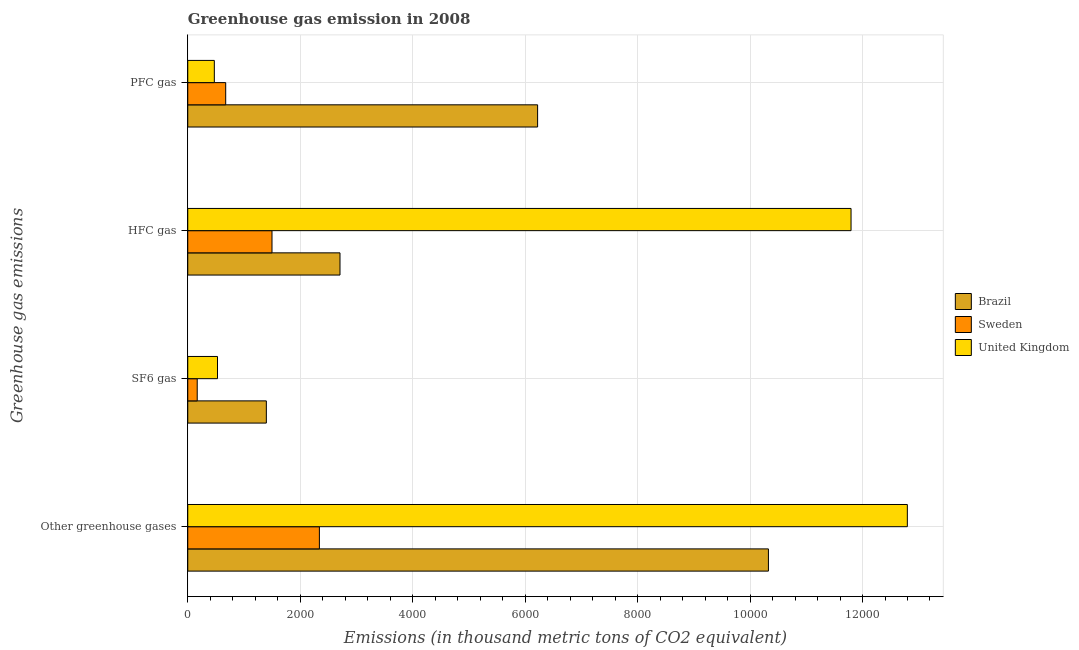How many groups of bars are there?
Make the answer very short. 4. Are the number of bars per tick equal to the number of legend labels?
Ensure brevity in your answer.  Yes. Are the number of bars on each tick of the Y-axis equal?
Keep it short and to the point. Yes. How many bars are there on the 1st tick from the top?
Offer a terse response. 3. How many bars are there on the 1st tick from the bottom?
Provide a short and direct response. 3. What is the label of the 3rd group of bars from the top?
Provide a succinct answer. SF6 gas. What is the emission of sf6 gas in United Kingdom?
Ensure brevity in your answer.  528.9. Across all countries, what is the maximum emission of sf6 gas?
Your response must be concise. 1397.3. Across all countries, what is the minimum emission of sf6 gas?
Give a very brief answer. 168.1. In which country was the emission of greenhouse gases maximum?
Offer a terse response. United Kingdom. What is the total emission of sf6 gas in the graph?
Ensure brevity in your answer.  2094.3. What is the difference between the emission of greenhouse gases in Brazil and that in Sweden?
Keep it short and to the point. 7985.7. What is the difference between the emission of sf6 gas in United Kingdom and the emission of hfc gas in Sweden?
Give a very brief answer. -969.1. What is the average emission of sf6 gas per country?
Your answer should be compact. 698.1. What is the difference between the emission of sf6 gas and emission of pfc gas in United Kingdom?
Give a very brief answer. 56.5. In how many countries, is the emission of pfc gas greater than 12800 thousand metric tons?
Provide a short and direct response. 0. What is the ratio of the emission of pfc gas in Brazil to that in United Kingdom?
Make the answer very short. 13.17. Is the emission of hfc gas in Brazil less than that in United Kingdom?
Your response must be concise. Yes. What is the difference between the highest and the second highest emission of hfc gas?
Offer a terse response. 9088.5. What is the difference between the highest and the lowest emission of sf6 gas?
Your answer should be very brief. 1229.2. In how many countries, is the emission of pfc gas greater than the average emission of pfc gas taken over all countries?
Your answer should be very brief. 1. Is it the case that in every country, the sum of the emission of greenhouse gases and emission of sf6 gas is greater than the emission of hfc gas?
Your answer should be very brief. Yes. How many countries are there in the graph?
Your response must be concise. 3. What is the difference between two consecutive major ticks on the X-axis?
Your response must be concise. 2000. Are the values on the major ticks of X-axis written in scientific E-notation?
Provide a succinct answer. No. Does the graph contain grids?
Your answer should be compact. Yes. Where does the legend appear in the graph?
Your response must be concise. Center right. How many legend labels are there?
Your answer should be very brief. 3. How are the legend labels stacked?
Make the answer very short. Vertical. What is the title of the graph?
Your response must be concise. Greenhouse gas emission in 2008. What is the label or title of the X-axis?
Provide a succinct answer. Emissions (in thousand metric tons of CO2 equivalent). What is the label or title of the Y-axis?
Offer a very short reply. Greenhouse gas emissions. What is the Emissions (in thousand metric tons of CO2 equivalent) of Brazil in Other greenhouse gases?
Ensure brevity in your answer.  1.03e+04. What is the Emissions (in thousand metric tons of CO2 equivalent) of Sweden in Other greenhouse gases?
Provide a short and direct response. 2340.9. What is the Emissions (in thousand metric tons of CO2 equivalent) of United Kingdom in Other greenhouse gases?
Provide a succinct answer. 1.28e+04. What is the Emissions (in thousand metric tons of CO2 equivalent) of Brazil in SF6 gas?
Provide a succinct answer. 1397.3. What is the Emissions (in thousand metric tons of CO2 equivalent) in Sweden in SF6 gas?
Your answer should be compact. 168.1. What is the Emissions (in thousand metric tons of CO2 equivalent) in United Kingdom in SF6 gas?
Your answer should be compact. 528.9. What is the Emissions (in thousand metric tons of CO2 equivalent) in Brazil in HFC gas?
Give a very brief answer. 2707.5. What is the Emissions (in thousand metric tons of CO2 equivalent) in Sweden in HFC gas?
Provide a short and direct response. 1498. What is the Emissions (in thousand metric tons of CO2 equivalent) in United Kingdom in HFC gas?
Offer a terse response. 1.18e+04. What is the Emissions (in thousand metric tons of CO2 equivalent) in Brazil in PFC gas?
Give a very brief answer. 6221.8. What is the Emissions (in thousand metric tons of CO2 equivalent) in Sweden in PFC gas?
Your answer should be compact. 674.8. What is the Emissions (in thousand metric tons of CO2 equivalent) in United Kingdom in PFC gas?
Your answer should be compact. 472.4. Across all Greenhouse gas emissions, what is the maximum Emissions (in thousand metric tons of CO2 equivalent) of Brazil?
Ensure brevity in your answer.  1.03e+04. Across all Greenhouse gas emissions, what is the maximum Emissions (in thousand metric tons of CO2 equivalent) in Sweden?
Make the answer very short. 2340.9. Across all Greenhouse gas emissions, what is the maximum Emissions (in thousand metric tons of CO2 equivalent) of United Kingdom?
Your response must be concise. 1.28e+04. Across all Greenhouse gas emissions, what is the minimum Emissions (in thousand metric tons of CO2 equivalent) in Brazil?
Offer a terse response. 1397.3. Across all Greenhouse gas emissions, what is the minimum Emissions (in thousand metric tons of CO2 equivalent) of Sweden?
Make the answer very short. 168.1. Across all Greenhouse gas emissions, what is the minimum Emissions (in thousand metric tons of CO2 equivalent) in United Kingdom?
Your answer should be very brief. 472.4. What is the total Emissions (in thousand metric tons of CO2 equivalent) in Brazil in the graph?
Ensure brevity in your answer.  2.07e+04. What is the total Emissions (in thousand metric tons of CO2 equivalent) in Sweden in the graph?
Offer a terse response. 4681.8. What is the total Emissions (in thousand metric tons of CO2 equivalent) of United Kingdom in the graph?
Provide a short and direct response. 2.56e+04. What is the difference between the Emissions (in thousand metric tons of CO2 equivalent) in Brazil in Other greenhouse gases and that in SF6 gas?
Provide a short and direct response. 8929.3. What is the difference between the Emissions (in thousand metric tons of CO2 equivalent) in Sweden in Other greenhouse gases and that in SF6 gas?
Offer a terse response. 2172.8. What is the difference between the Emissions (in thousand metric tons of CO2 equivalent) in United Kingdom in Other greenhouse gases and that in SF6 gas?
Make the answer very short. 1.23e+04. What is the difference between the Emissions (in thousand metric tons of CO2 equivalent) of Brazil in Other greenhouse gases and that in HFC gas?
Offer a very short reply. 7619.1. What is the difference between the Emissions (in thousand metric tons of CO2 equivalent) of Sweden in Other greenhouse gases and that in HFC gas?
Your answer should be compact. 842.9. What is the difference between the Emissions (in thousand metric tons of CO2 equivalent) in United Kingdom in Other greenhouse gases and that in HFC gas?
Your answer should be very brief. 1001.3. What is the difference between the Emissions (in thousand metric tons of CO2 equivalent) in Brazil in Other greenhouse gases and that in PFC gas?
Offer a very short reply. 4104.8. What is the difference between the Emissions (in thousand metric tons of CO2 equivalent) of Sweden in Other greenhouse gases and that in PFC gas?
Your response must be concise. 1666.1. What is the difference between the Emissions (in thousand metric tons of CO2 equivalent) in United Kingdom in Other greenhouse gases and that in PFC gas?
Offer a terse response. 1.23e+04. What is the difference between the Emissions (in thousand metric tons of CO2 equivalent) of Brazil in SF6 gas and that in HFC gas?
Provide a short and direct response. -1310.2. What is the difference between the Emissions (in thousand metric tons of CO2 equivalent) in Sweden in SF6 gas and that in HFC gas?
Provide a succinct answer. -1329.9. What is the difference between the Emissions (in thousand metric tons of CO2 equivalent) of United Kingdom in SF6 gas and that in HFC gas?
Your response must be concise. -1.13e+04. What is the difference between the Emissions (in thousand metric tons of CO2 equivalent) in Brazil in SF6 gas and that in PFC gas?
Provide a succinct answer. -4824.5. What is the difference between the Emissions (in thousand metric tons of CO2 equivalent) in Sweden in SF6 gas and that in PFC gas?
Make the answer very short. -506.7. What is the difference between the Emissions (in thousand metric tons of CO2 equivalent) in United Kingdom in SF6 gas and that in PFC gas?
Provide a short and direct response. 56.5. What is the difference between the Emissions (in thousand metric tons of CO2 equivalent) in Brazil in HFC gas and that in PFC gas?
Make the answer very short. -3514.3. What is the difference between the Emissions (in thousand metric tons of CO2 equivalent) of Sweden in HFC gas and that in PFC gas?
Offer a terse response. 823.2. What is the difference between the Emissions (in thousand metric tons of CO2 equivalent) in United Kingdom in HFC gas and that in PFC gas?
Keep it short and to the point. 1.13e+04. What is the difference between the Emissions (in thousand metric tons of CO2 equivalent) in Brazil in Other greenhouse gases and the Emissions (in thousand metric tons of CO2 equivalent) in Sweden in SF6 gas?
Offer a very short reply. 1.02e+04. What is the difference between the Emissions (in thousand metric tons of CO2 equivalent) of Brazil in Other greenhouse gases and the Emissions (in thousand metric tons of CO2 equivalent) of United Kingdom in SF6 gas?
Make the answer very short. 9797.7. What is the difference between the Emissions (in thousand metric tons of CO2 equivalent) in Sweden in Other greenhouse gases and the Emissions (in thousand metric tons of CO2 equivalent) in United Kingdom in SF6 gas?
Offer a very short reply. 1812. What is the difference between the Emissions (in thousand metric tons of CO2 equivalent) of Brazil in Other greenhouse gases and the Emissions (in thousand metric tons of CO2 equivalent) of Sweden in HFC gas?
Make the answer very short. 8828.6. What is the difference between the Emissions (in thousand metric tons of CO2 equivalent) in Brazil in Other greenhouse gases and the Emissions (in thousand metric tons of CO2 equivalent) in United Kingdom in HFC gas?
Your response must be concise. -1469.4. What is the difference between the Emissions (in thousand metric tons of CO2 equivalent) of Sweden in Other greenhouse gases and the Emissions (in thousand metric tons of CO2 equivalent) of United Kingdom in HFC gas?
Provide a succinct answer. -9455.1. What is the difference between the Emissions (in thousand metric tons of CO2 equivalent) of Brazil in Other greenhouse gases and the Emissions (in thousand metric tons of CO2 equivalent) of Sweden in PFC gas?
Your response must be concise. 9651.8. What is the difference between the Emissions (in thousand metric tons of CO2 equivalent) in Brazil in Other greenhouse gases and the Emissions (in thousand metric tons of CO2 equivalent) in United Kingdom in PFC gas?
Offer a very short reply. 9854.2. What is the difference between the Emissions (in thousand metric tons of CO2 equivalent) of Sweden in Other greenhouse gases and the Emissions (in thousand metric tons of CO2 equivalent) of United Kingdom in PFC gas?
Make the answer very short. 1868.5. What is the difference between the Emissions (in thousand metric tons of CO2 equivalent) in Brazil in SF6 gas and the Emissions (in thousand metric tons of CO2 equivalent) in Sweden in HFC gas?
Your answer should be very brief. -100.7. What is the difference between the Emissions (in thousand metric tons of CO2 equivalent) of Brazil in SF6 gas and the Emissions (in thousand metric tons of CO2 equivalent) of United Kingdom in HFC gas?
Ensure brevity in your answer.  -1.04e+04. What is the difference between the Emissions (in thousand metric tons of CO2 equivalent) of Sweden in SF6 gas and the Emissions (in thousand metric tons of CO2 equivalent) of United Kingdom in HFC gas?
Your response must be concise. -1.16e+04. What is the difference between the Emissions (in thousand metric tons of CO2 equivalent) of Brazil in SF6 gas and the Emissions (in thousand metric tons of CO2 equivalent) of Sweden in PFC gas?
Provide a succinct answer. 722.5. What is the difference between the Emissions (in thousand metric tons of CO2 equivalent) in Brazil in SF6 gas and the Emissions (in thousand metric tons of CO2 equivalent) in United Kingdom in PFC gas?
Offer a terse response. 924.9. What is the difference between the Emissions (in thousand metric tons of CO2 equivalent) in Sweden in SF6 gas and the Emissions (in thousand metric tons of CO2 equivalent) in United Kingdom in PFC gas?
Your answer should be very brief. -304.3. What is the difference between the Emissions (in thousand metric tons of CO2 equivalent) in Brazil in HFC gas and the Emissions (in thousand metric tons of CO2 equivalent) in Sweden in PFC gas?
Keep it short and to the point. 2032.7. What is the difference between the Emissions (in thousand metric tons of CO2 equivalent) of Brazil in HFC gas and the Emissions (in thousand metric tons of CO2 equivalent) of United Kingdom in PFC gas?
Your response must be concise. 2235.1. What is the difference between the Emissions (in thousand metric tons of CO2 equivalent) of Sweden in HFC gas and the Emissions (in thousand metric tons of CO2 equivalent) of United Kingdom in PFC gas?
Your answer should be very brief. 1025.6. What is the average Emissions (in thousand metric tons of CO2 equivalent) of Brazil per Greenhouse gas emissions?
Your answer should be compact. 5163.3. What is the average Emissions (in thousand metric tons of CO2 equivalent) in Sweden per Greenhouse gas emissions?
Offer a terse response. 1170.45. What is the average Emissions (in thousand metric tons of CO2 equivalent) of United Kingdom per Greenhouse gas emissions?
Offer a very short reply. 6398.65. What is the difference between the Emissions (in thousand metric tons of CO2 equivalent) in Brazil and Emissions (in thousand metric tons of CO2 equivalent) in Sweden in Other greenhouse gases?
Offer a terse response. 7985.7. What is the difference between the Emissions (in thousand metric tons of CO2 equivalent) in Brazil and Emissions (in thousand metric tons of CO2 equivalent) in United Kingdom in Other greenhouse gases?
Offer a very short reply. -2470.7. What is the difference between the Emissions (in thousand metric tons of CO2 equivalent) of Sweden and Emissions (in thousand metric tons of CO2 equivalent) of United Kingdom in Other greenhouse gases?
Your answer should be compact. -1.05e+04. What is the difference between the Emissions (in thousand metric tons of CO2 equivalent) of Brazil and Emissions (in thousand metric tons of CO2 equivalent) of Sweden in SF6 gas?
Offer a very short reply. 1229.2. What is the difference between the Emissions (in thousand metric tons of CO2 equivalent) of Brazil and Emissions (in thousand metric tons of CO2 equivalent) of United Kingdom in SF6 gas?
Your answer should be compact. 868.4. What is the difference between the Emissions (in thousand metric tons of CO2 equivalent) of Sweden and Emissions (in thousand metric tons of CO2 equivalent) of United Kingdom in SF6 gas?
Provide a short and direct response. -360.8. What is the difference between the Emissions (in thousand metric tons of CO2 equivalent) of Brazil and Emissions (in thousand metric tons of CO2 equivalent) of Sweden in HFC gas?
Make the answer very short. 1209.5. What is the difference between the Emissions (in thousand metric tons of CO2 equivalent) of Brazil and Emissions (in thousand metric tons of CO2 equivalent) of United Kingdom in HFC gas?
Give a very brief answer. -9088.5. What is the difference between the Emissions (in thousand metric tons of CO2 equivalent) in Sweden and Emissions (in thousand metric tons of CO2 equivalent) in United Kingdom in HFC gas?
Offer a terse response. -1.03e+04. What is the difference between the Emissions (in thousand metric tons of CO2 equivalent) in Brazil and Emissions (in thousand metric tons of CO2 equivalent) in Sweden in PFC gas?
Your response must be concise. 5547. What is the difference between the Emissions (in thousand metric tons of CO2 equivalent) in Brazil and Emissions (in thousand metric tons of CO2 equivalent) in United Kingdom in PFC gas?
Your response must be concise. 5749.4. What is the difference between the Emissions (in thousand metric tons of CO2 equivalent) in Sweden and Emissions (in thousand metric tons of CO2 equivalent) in United Kingdom in PFC gas?
Offer a very short reply. 202.4. What is the ratio of the Emissions (in thousand metric tons of CO2 equivalent) of Brazil in Other greenhouse gases to that in SF6 gas?
Offer a very short reply. 7.39. What is the ratio of the Emissions (in thousand metric tons of CO2 equivalent) of Sweden in Other greenhouse gases to that in SF6 gas?
Offer a very short reply. 13.93. What is the ratio of the Emissions (in thousand metric tons of CO2 equivalent) in United Kingdom in Other greenhouse gases to that in SF6 gas?
Offer a very short reply. 24.2. What is the ratio of the Emissions (in thousand metric tons of CO2 equivalent) in Brazil in Other greenhouse gases to that in HFC gas?
Provide a short and direct response. 3.81. What is the ratio of the Emissions (in thousand metric tons of CO2 equivalent) in Sweden in Other greenhouse gases to that in HFC gas?
Provide a short and direct response. 1.56. What is the ratio of the Emissions (in thousand metric tons of CO2 equivalent) of United Kingdom in Other greenhouse gases to that in HFC gas?
Provide a short and direct response. 1.08. What is the ratio of the Emissions (in thousand metric tons of CO2 equivalent) in Brazil in Other greenhouse gases to that in PFC gas?
Keep it short and to the point. 1.66. What is the ratio of the Emissions (in thousand metric tons of CO2 equivalent) of Sweden in Other greenhouse gases to that in PFC gas?
Provide a short and direct response. 3.47. What is the ratio of the Emissions (in thousand metric tons of CO2 equivalent) of United Kingdom in Other greenhouse gases to that in PFC gas?
Keep it short and to the point. 27.09. What is the ratio of the Emissions (in thousand metric tons of CO2 equivalent) in Brazil in SF6 gas to that in HFC gas?
Provide a short and direct response. 0.52. What is the ratio of the Emissions (in thousand metric tons of CO2 equivalent) in Sweden in SF6 gas to that in HFC gas?
Offer a terse response. 0.11. What is the ratio of the Emissions (in thousand metric tons of CO2 equivalent) in United Kingdom in SF6 gas to that in HFC gas?
Your answer should be very brief. 0.04. What is the ratio of the Emissions (in thousand metric tons of CO2 equivalent) of Brazil in SF6 gas to that in PFC gas?
Make the answer very short. 0.22. What is the ratio of the Emissions (in thousand metric tons of CO2 equivalent) of Sweden in SF6 gas to that in PFC gas?
Make the answer very short. 0.25. What is the ratio of the Emissions (in thousand metric tons of CO2 equivalent) in United Kingdom in SF6 gas to that in PFC gas?
Your response must be concise. 1.12. What is the ratio of the Emissions (in thousand metric tons of CO2 equivalent) of Brazil in HFC gas to that in PFC gas?
Offer a very short reply. 0.44. What is the ratio of the Emissions (in thousand metric tons of CO2 equivalent) in Sweden in HFC gas to that in PFC gas?
Offer a terse response. 2.22. What is the ratio of the Emissions (in thousand metric tons of CO2 equivalent) of United Kingdom in HFC gas to that in PFC gas?
Provide a succinct answer. 24.97. What is the difference between the highest and the second highest Emissions (in thousand metric tons of CO2 equivalent) of Brazil?
Provide a short and direct response. 4104.8. What is the difference between the highest and the second highest Emissions (in thousand metric tons of CO2 equivalent) in Sweden?
Provide a succinct answer. 842.9. What is the difference between the highest and the second highest Emissions (in thousand metric tons of CO2 equivalent) in United Kingdom?
Offer a terse response. 1001.3. What is the difference between the highest and the lowest Emissions (in thousand metric tons of CO2 equivalent) of Brazil?
Provide a succinct answer. 8929.3. What is the difference between the highest and the lowest Emissions (in thousand metric tons of CO2 equivalent) of Sweden?
Offer a terse response. 2172.8. What is the difference between the highest and the lowest Emissions (in thousand metric tons of CO2 equivalent) in United Kingdom?
Keep it short and to the point. 1.23e+04. 